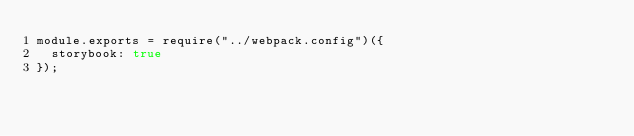Convert code to text. <code><loc_0><loc_0><loc_500><loc_500><_JavaScript_>module.exports = require("../webpack.config")({
  storybook: true
});
</code> 